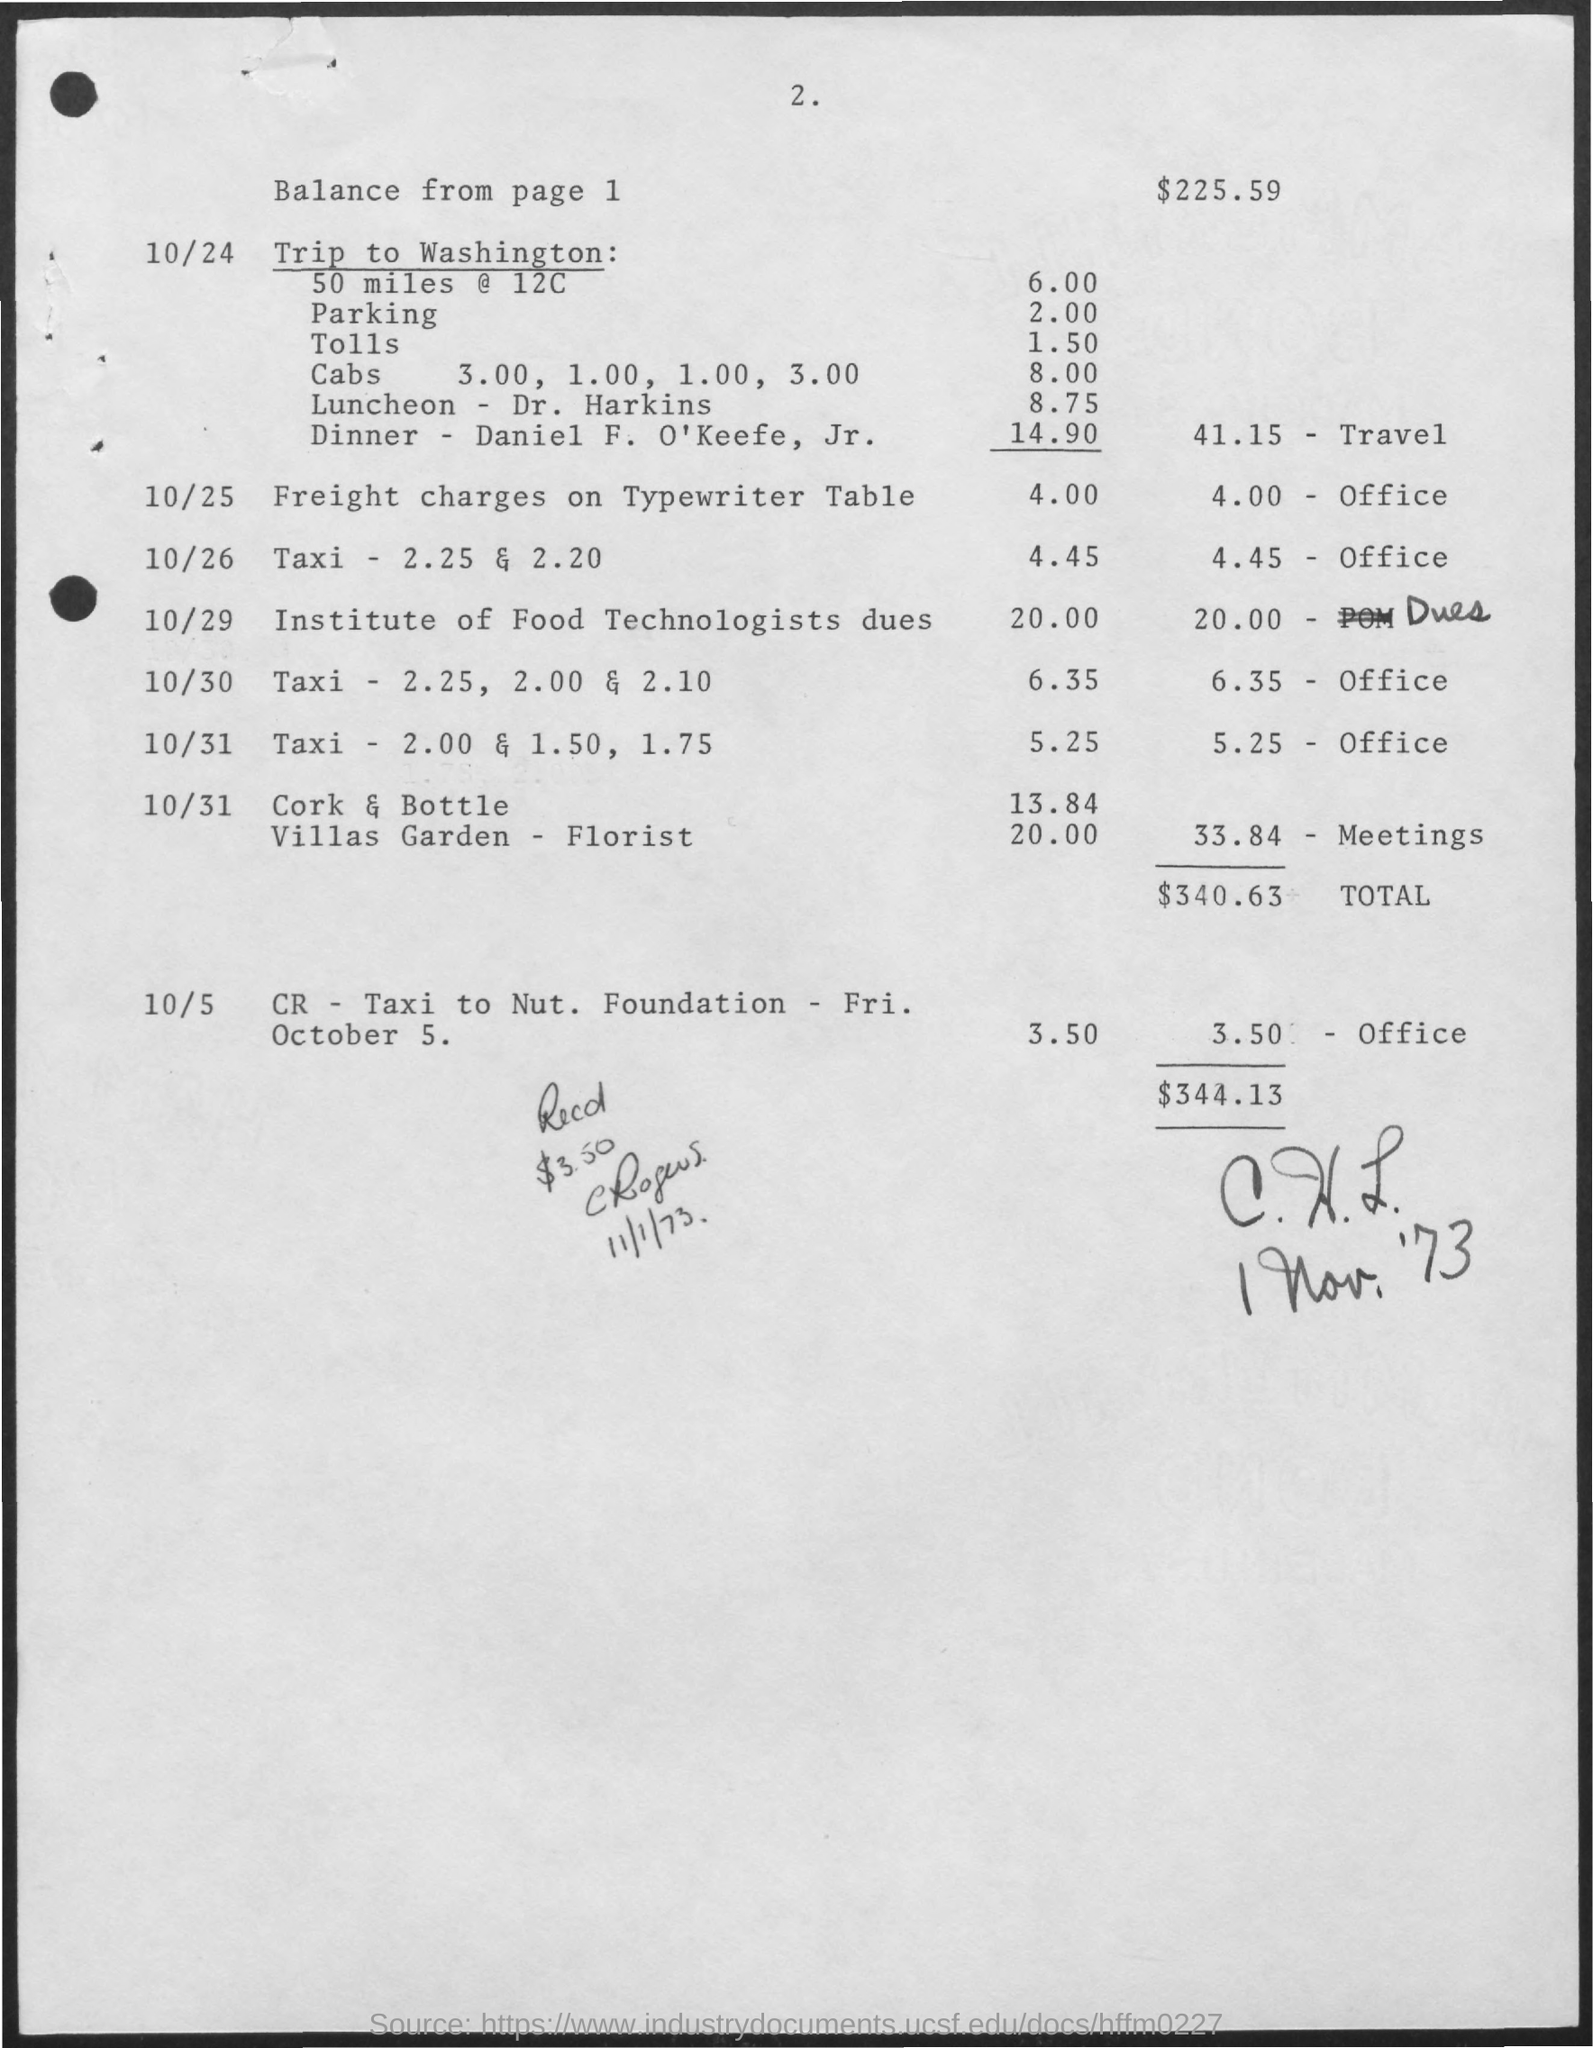How much for Parking?
Your answer should be very brief. 2.00. How much for tolls?
Offer a terse response. 1.50. How much for Luncheon - Dr. Harkins?
Make the answer very short. 8.75. How much for Dinner - Daniel F. O'Keefe, Jr.?
Keep it short and to the point. 14.90. How much for Cabs?
Offer a very short reply. 8.00. 